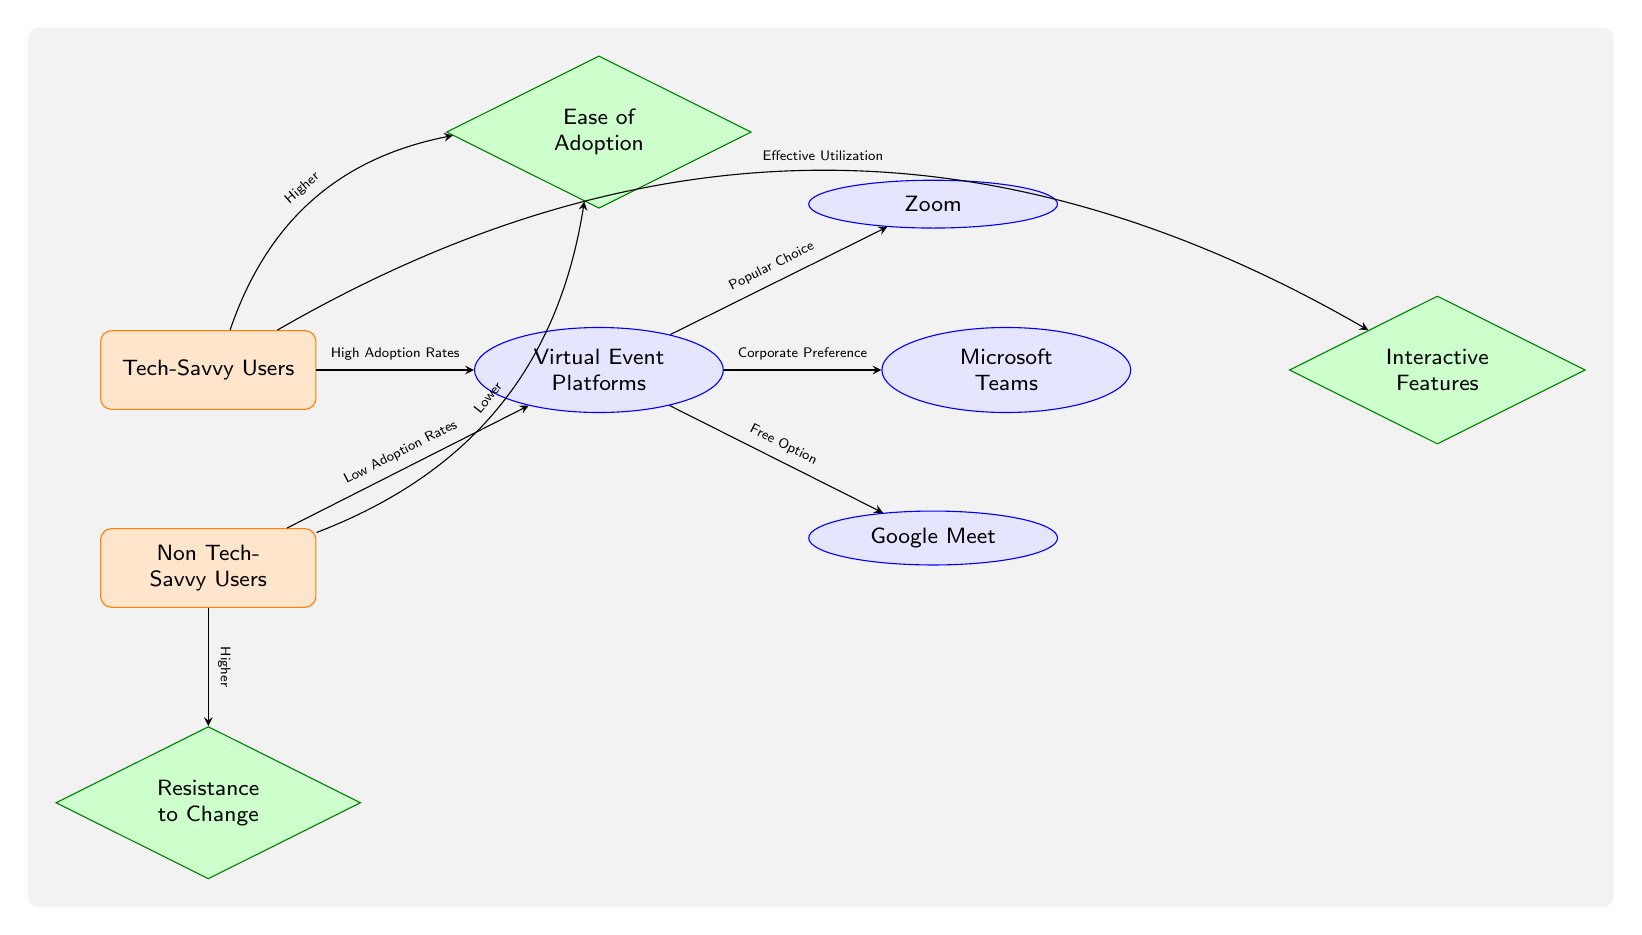What is the relationship between Tech-Savvy Users and Virtual Event Platforms? The diagram indicates that Tech-Savvy Users have a "High Adoption Rates" connection to Virtual Event Platforms, showing a positive relationship.
Answer: High Adoption Rates What feature is associated with Non Tech-Savvy Users in relation to Ease of Adoption? Non Tech-Savvy Users are linked to "Lower" regarding the Ease of Adoption, signaling their difficulty in adopting these platforms.
Answer: Lower Which platform is labeled as a "Corporate Preference"? The diagram shows that Microsoft Teams is specifically connected with the label "Corporate Preference", identifying it among virtual platforms.
Answer: Microsoft Teams How many nodes represent Virtual Event Platforms in the diagram? There are a total of three nodes that represent different Virtual Event Platforms: Zoom, Microsoft Teams, and Google Meet, which makes it three nodes.
Answer: 3 What does the node interact feature indicate for Tech-Savvy Users? The diagram reveals that Tech-Savvy Users have a connection labeled "Higher" to the Interactive Features, indicating their stronger engagement with these features.
Answer: Higher What role does Resistance to Change play in Non Tech-Savvy Users' connection to Virtual Event Platforms? Non Tech-Savvy Users are related to a "Higher" degree of Resistance to Change, which affects their adoption of Virtual Event Platforms.
Answer: Higher What is one of the distinguishing features between Tech-Savvy and Non Tech-Savvy Users? The distinguishing feature indicated in the diagram is that Tech-Savvy Users have "Effective Utilization" of features, while Non Tech-Savvy Users do not have this prospect.
Answer: Effective Utilization Which platform is noted as a "Free Option"? Google Meet is indicated as the "Free Option" among the Virtual Event Platforms in the diagram.
Answer: Google Meet What is the connection between Tech-Savvy Users and Ease of Adoption? The diagram shows that Tech-Savvy Users have a "Higher" connection concerning the Ease of Adoption, highlighting their ability to adapt quickly.
Answer: Higher 